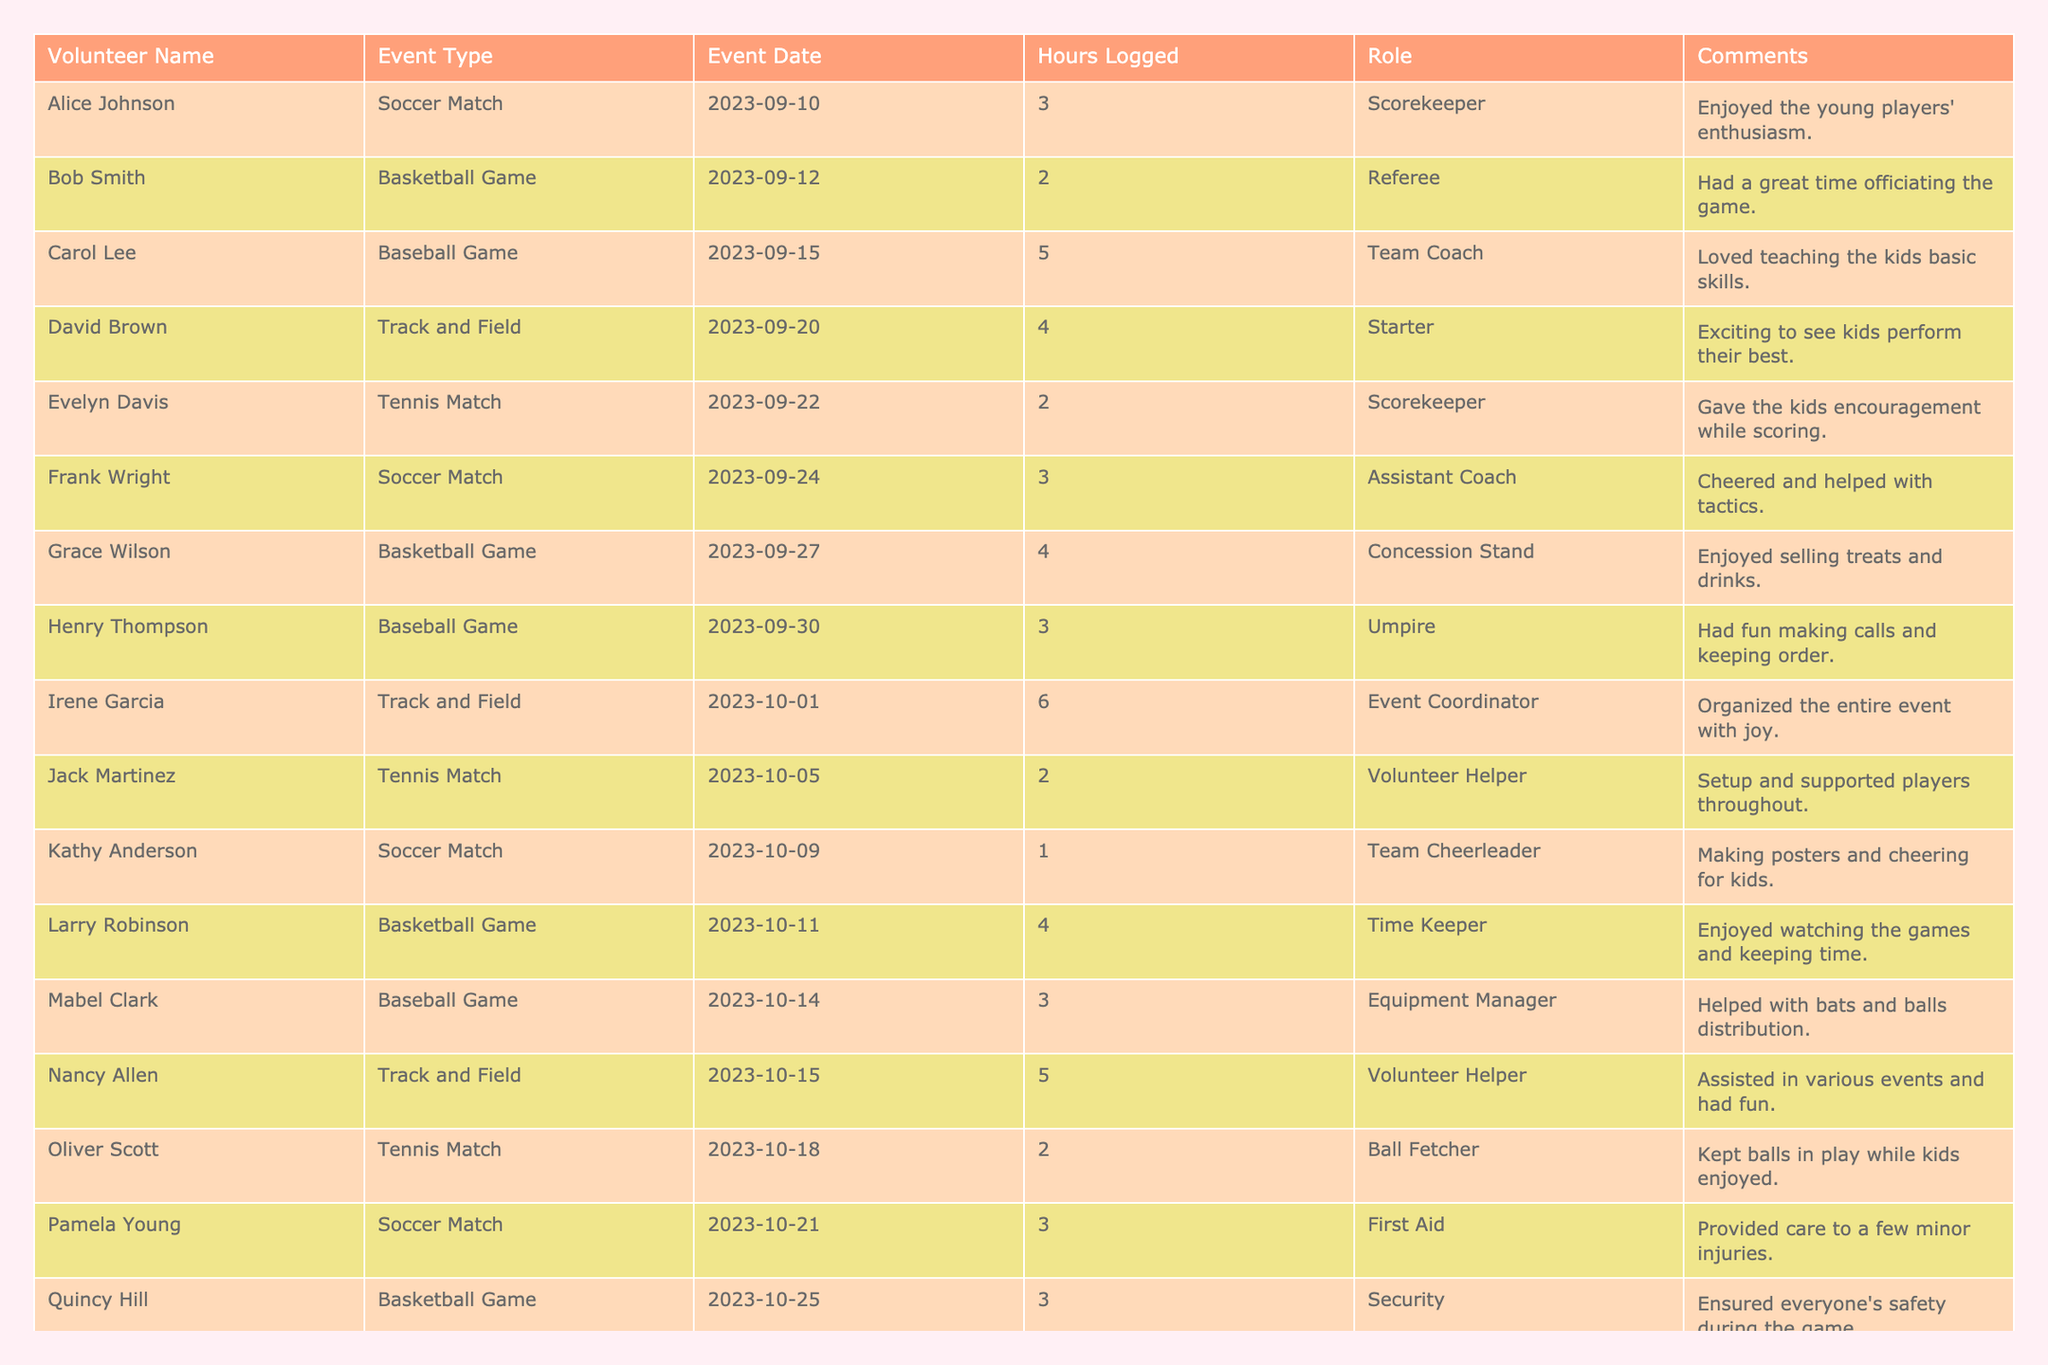What is the total number of volunteer hours logged? By adding up the Hours Logged for each volunteer: 3 + 2 + 5 + 4 + 2 + 3 + 4 + 3 + 6 + 2 + 1 + 4 + 3 + 5 + 2 + 3 + 4 + 2 = 58 hours.
Answer: 58 Which volunteer logged the most hours? Looking through the Hours Logged column, Irene Garcia logged the highest amount with 6 hours.
Answer: Irene Garcia How many different event types were there? The unique Event Types listed are Soccer Match, Basketball Game, Baseball Game, Track and Field, and Tennis Match, totaling 5 distinct types.
Answer: 5 What is the average number of hours logged per event type? First, sum the hours per event type: Soccer (3+3+1+3=10), Basketball (2+4+3=9), Baseball (5+3+3=11), Track (4+6+5+4=19), Tennis (2+2+2=6). Then calculate the average: (10+9+11+19+6)/5 = 11.
Answer: 11 Did any volunteer serve as an Event Coordinator? Yes, Irene Garcia served as the Event Coordinator.
Answer: Yes Which event type has the maximum total hours logged? Adding the hours for each event type gives Soccer (10), Basketball (9), Baseball (11), Track (19), and Tennis (6). Track and Field has the highest total of 19 hours logged.
Answer: Track and Field How many volunteers logged more than 3 hours? The volunteers with more than 3 hours are Carol Lee (5), Irene Garcia (6), Larry Robinson (4), Nancy Allen (5), and Steve Carter (4), totaling 5 volunteers.
Answer: 5 Are there any volunteers who logged only 1 hour? Yes, Kathy Anderson logged only 1 hour.
Answer: Yes What percentage of the volunteering hours were logged by the volunteers who acted as coaches? The total hours logged by coaches are: Carol Lee (5) and Frank Wright (3), giving us 8 hours. The total hours logged is 58, so (8/58)*100 = approximately 13.79%.
Answer: 13.79% What was the role of the volunteer who logged 2 hours at the Tennis Match? Jack Martinez was the Volunteer Helper and logged 2 hours for the Tennis Match.
Answer: Volunteer Helper 